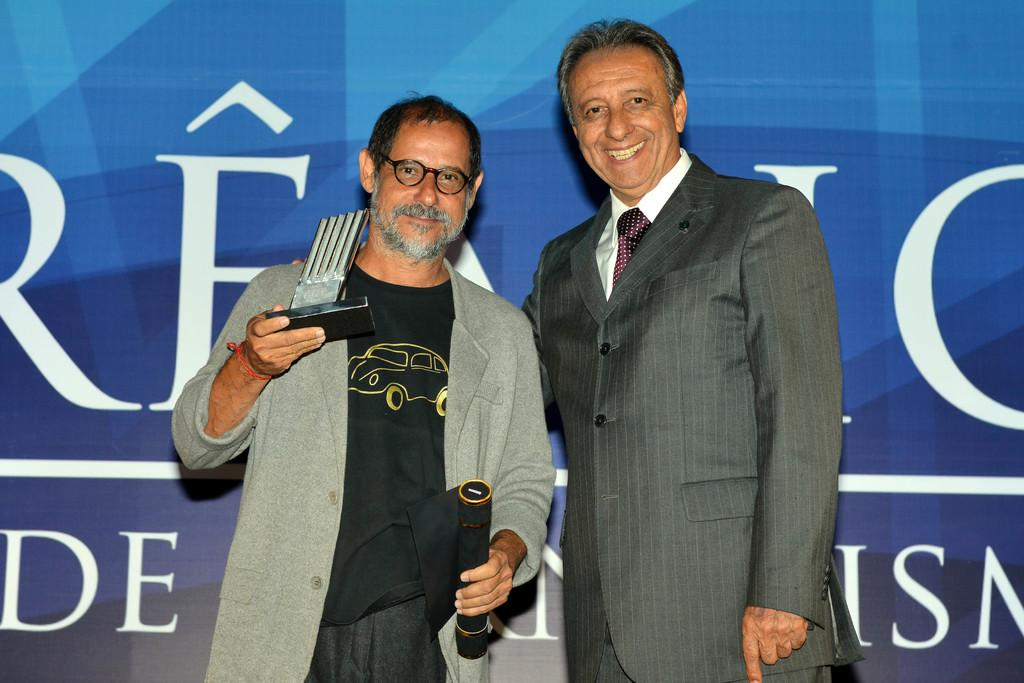What is in the background of the image? There is a banner in the background of the image. What are the men in the image doing? The men in the image are standing and smiling. Can you describe the position of the man on the left side of the image? The man on the left side of the image is standing. What is the man on the left side holding in his hands? The man on the left side is holding objects in his hands. Can you see any ghosts in the image? There are no ghosts present in the image. What type of harmony is being played by the men in the image? There is no indication of any music or harmony being played in the image. 